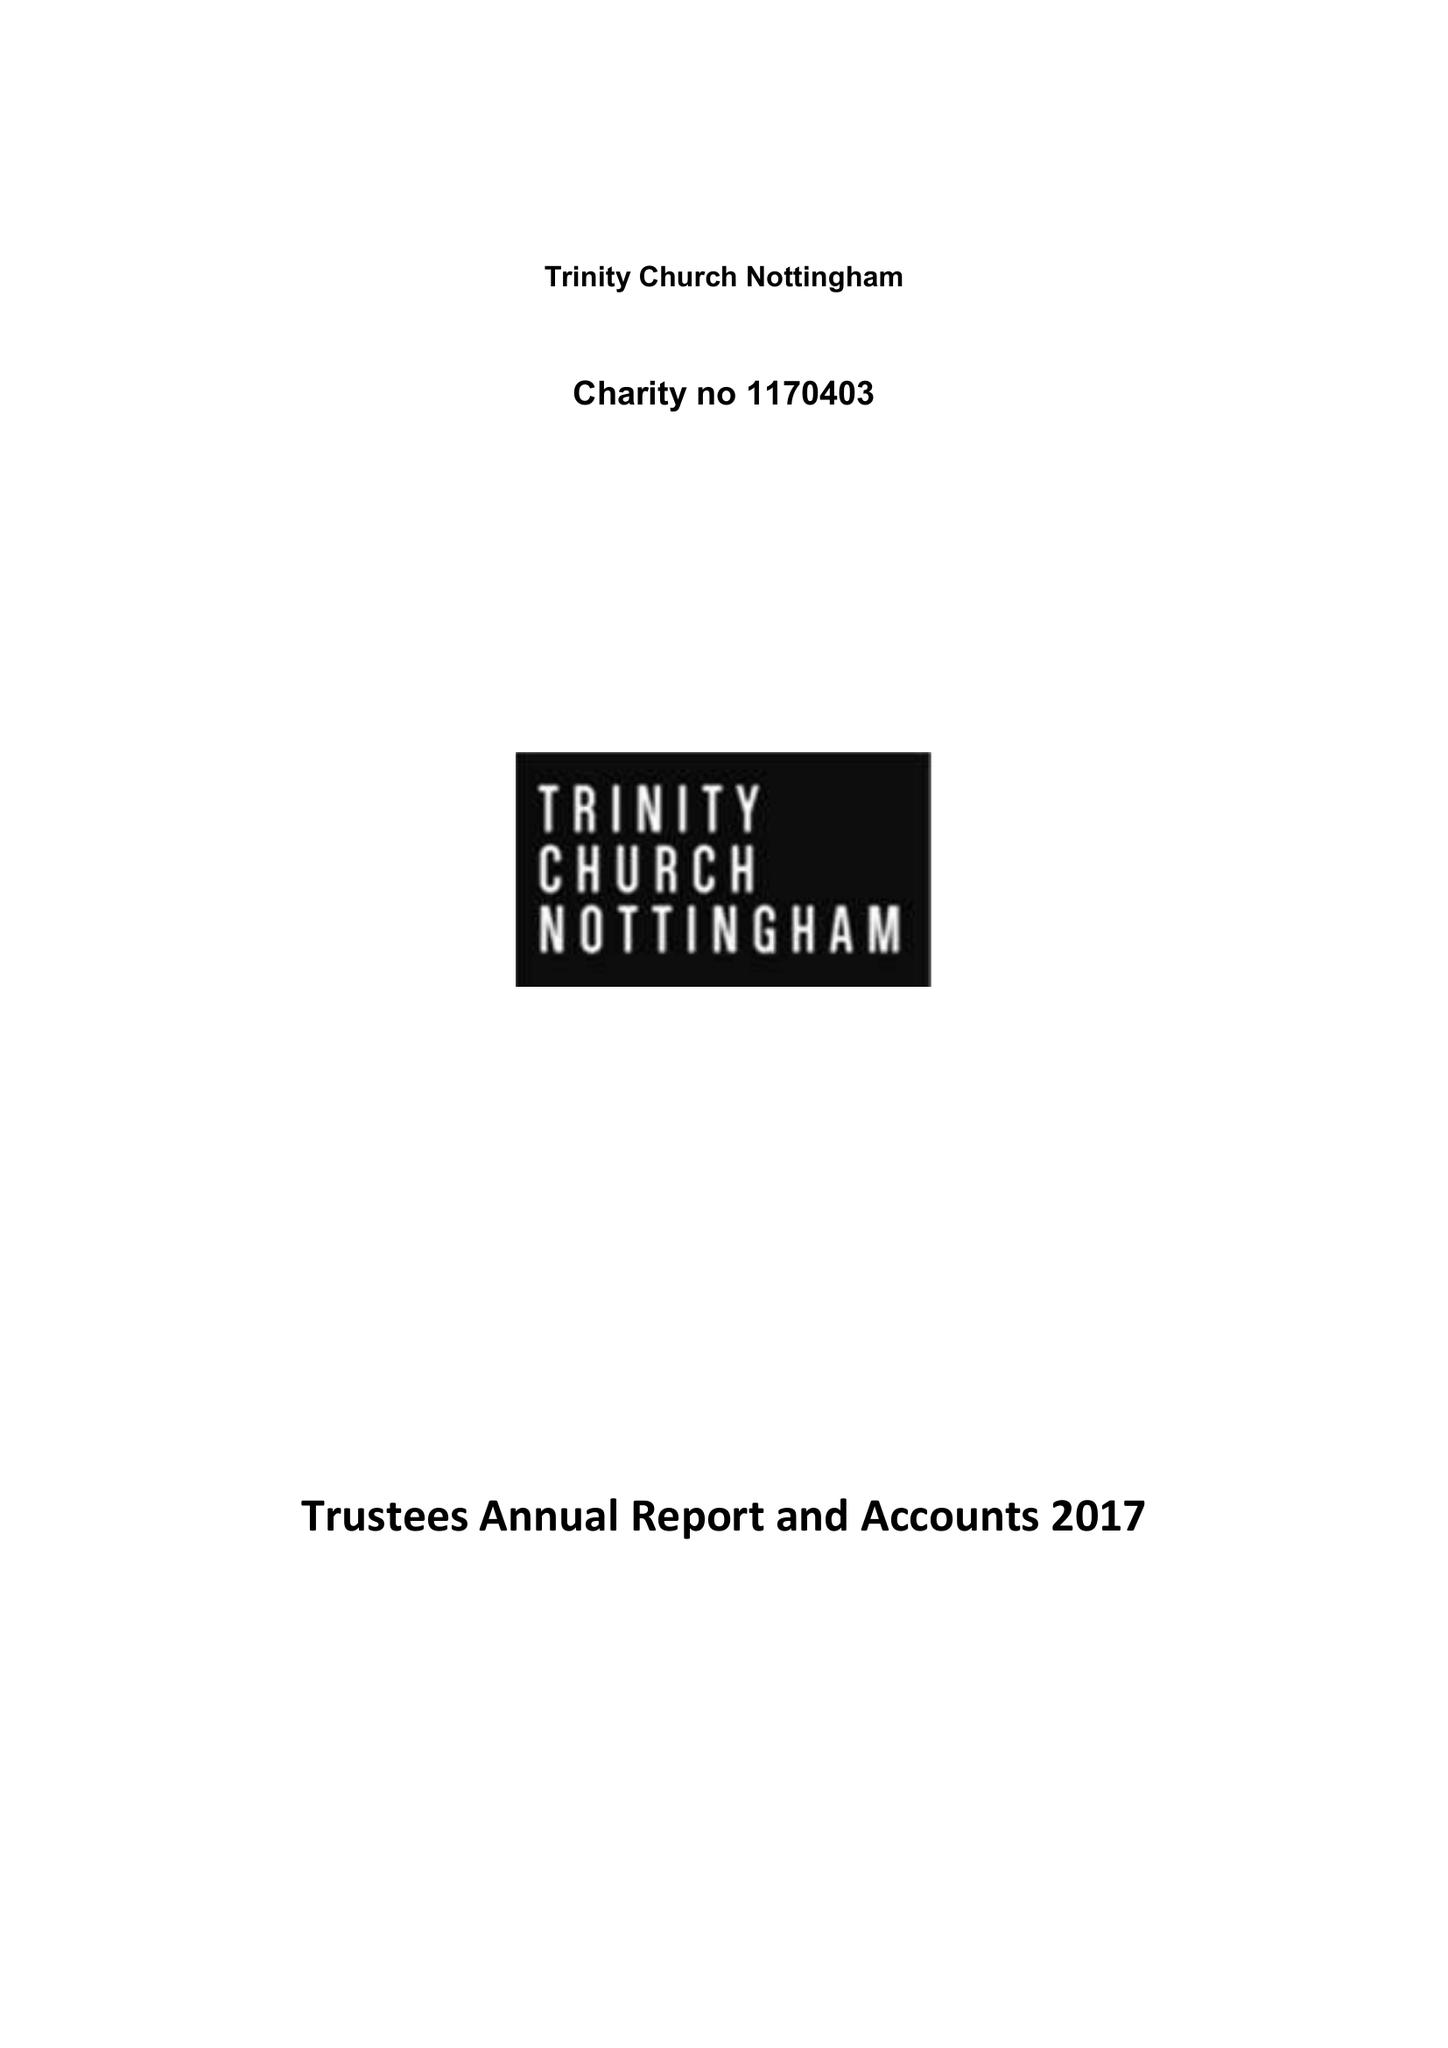What is the value for the address__postcode?
Answer the question using a single word or phrase. NG1 3HX 